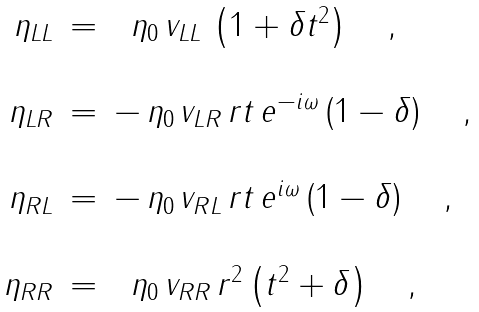<formula> <loc_0><loc_0><loc_500><loc_500>\begin{array} { r c l } \eta _ { L L } & = & \ \, \eta _ { 0 } \, v _ { L L } \, \left ( 1 + \delta t ^ { 2 } \right ) \quad , \\ \\ \eta _ { L R } & = & - \, \eta _ { 0 } \, v _ { L R } \, r t \, e ^ { - i \omega } \left ( 1 - \delta \right ) \quad , \\ \\ \eta _ { R L } & = & - \, \eta _ { 0 } \, v _ { R L } \, r t \, e ^ { i \omega } \left ( 1 - \delta \right ) \quad , \\ \\ \eta _ { R R } & = & \ \, \eta _ { 0 } \, v _ { R R } \, r ^ { 2 } \left ( t ^ { 2 } + \delta \right ) \quad , \end{array}</formula> 